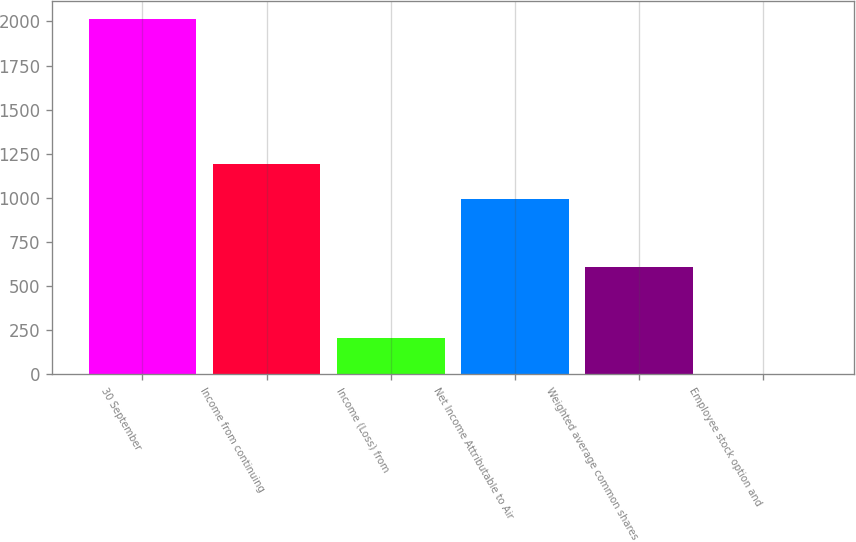Convert chart to OTSL. <chart><loc_0><loc_0><loc_500><loc_500><bar_chart><fcel>30 September<fcel>Income from continuing<fcel>Income (Loss) from<fcel>Net Income Attributable to Air<fcel>Weighted average common shares<fcel>Employee stock option and<nl><fcel>2014<fcel>1192.85<fcel>203.65<fcel>991.7<fcel>605.95<fcel>2.5<nl></chart> 